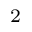Convert formula to latex. <formula><loc_0><loc_0><loc_500><loc_500>^ { 2 }</formula> 